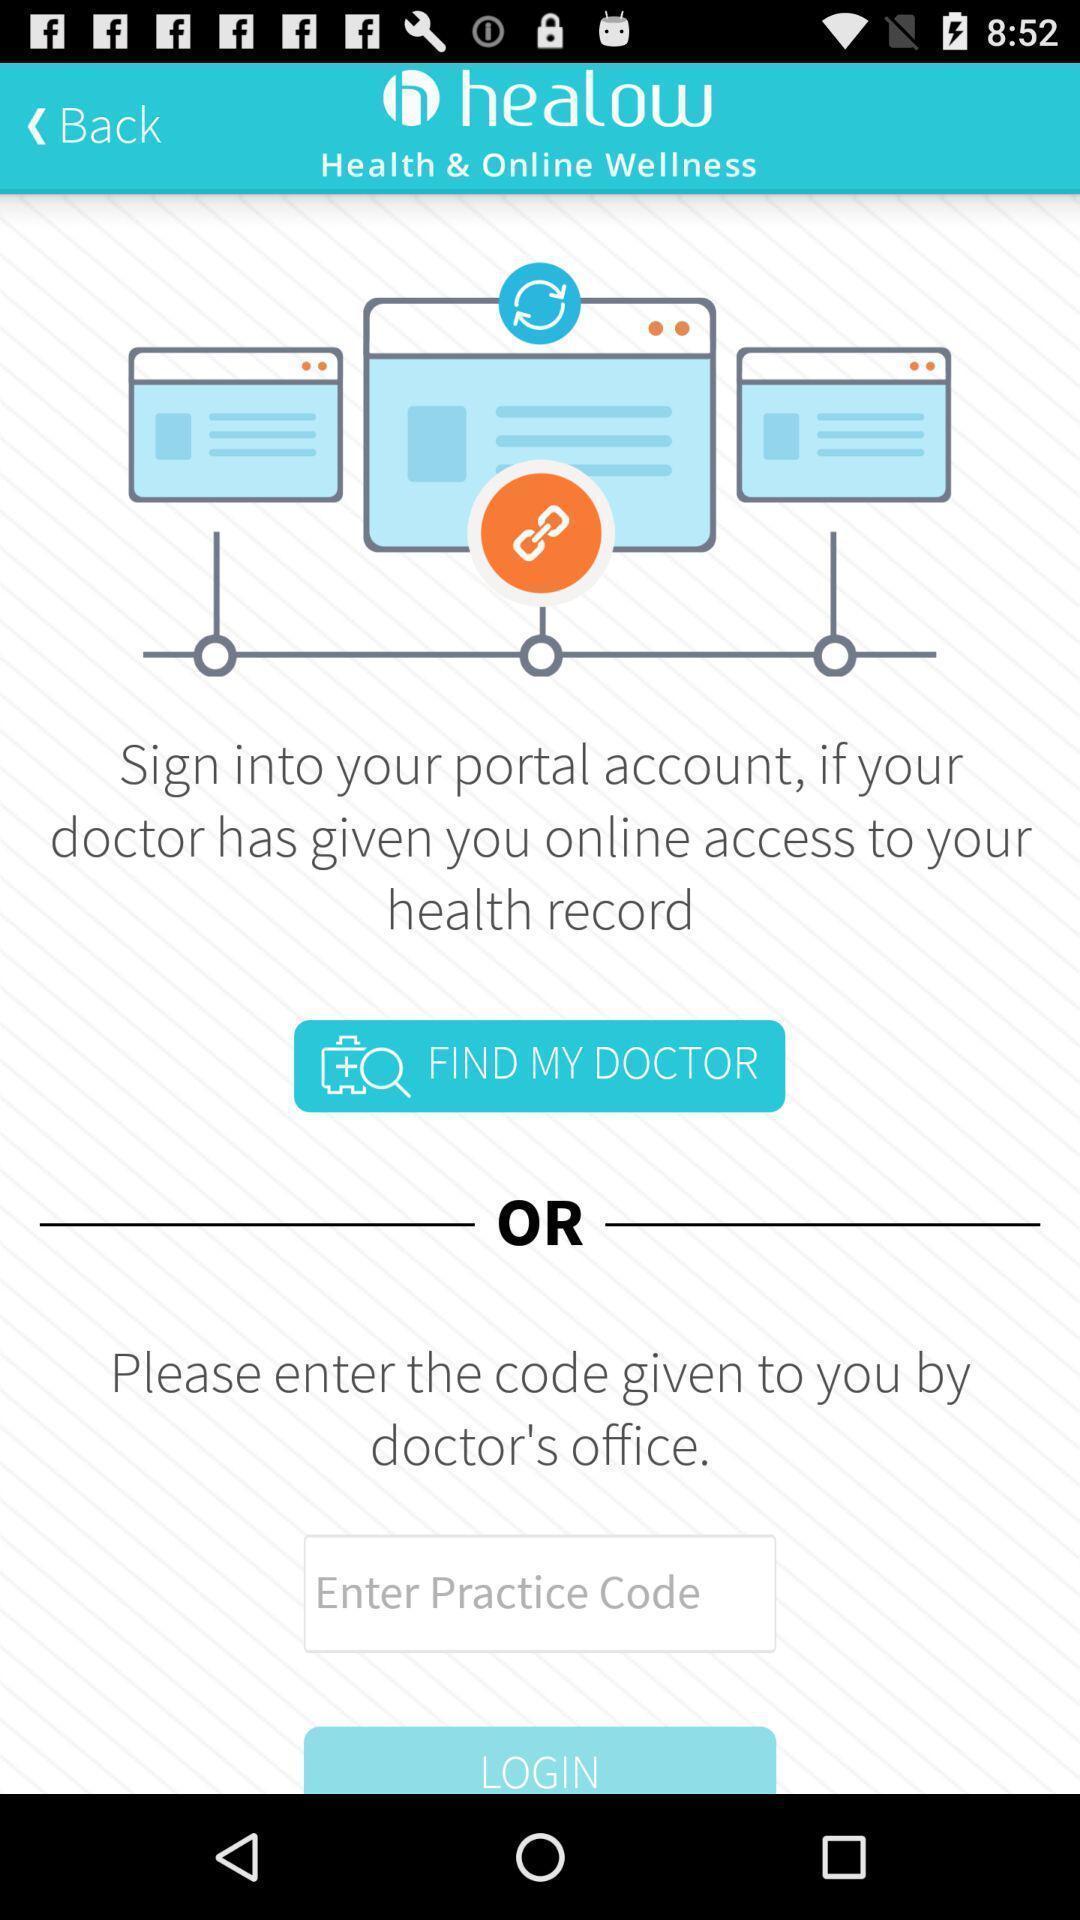Provide a detailed account of this screenshot. Sign in page to enter a code to find doctor. 